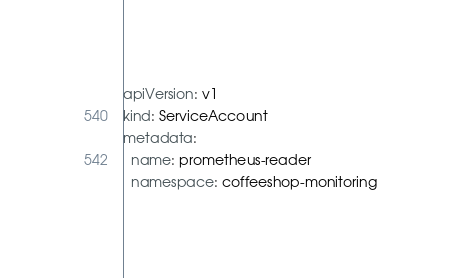<code> <loc_0><loc_0><loc_500><loc_500><_YAML_>apiVersion: v1
kind: ServiceAccount
metadata:
  name: prometheus-reader
  namespace: coffeeshop-monitoring
</code> 